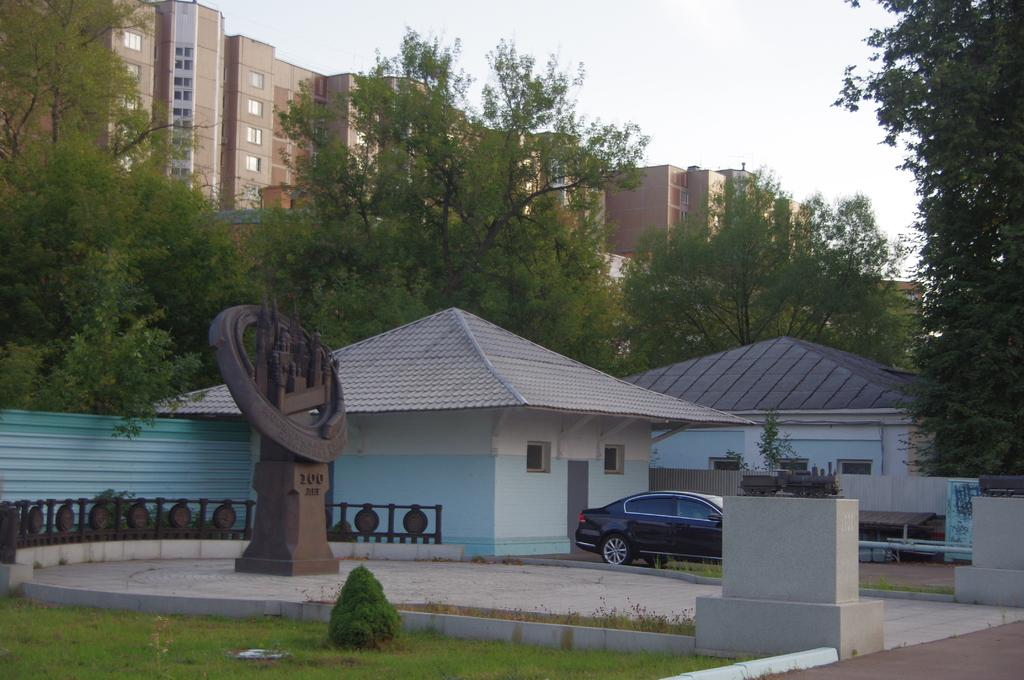What is the main subject of the image? The main subject of the image is a car. What can be seen in the background of the image? There are buildings with windows and trees in the image. What is visible in the sky in the image? The sky is visible in the background of the image. Where is the kitten sitting on the page in the image? There is no kitten or page present in the image. 